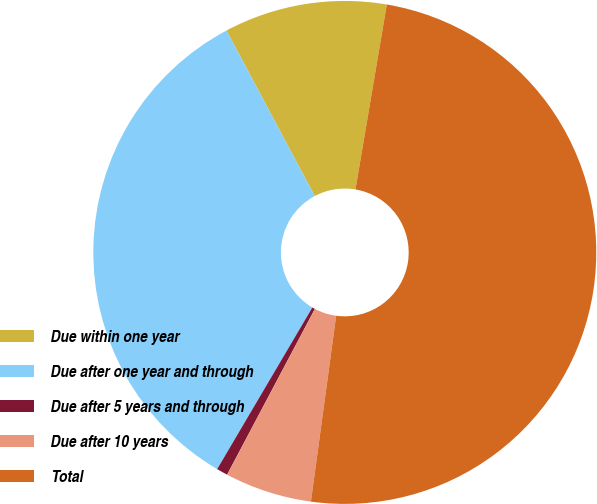Convert chart to OTSL. <chart><loc_0><loc_0><loc_500><loc_500><pie_chart><fcel>Due within one year<fcel>Due after one year and through<fcel>Due after 5 years and through<fcel>Due after 10 years<fcel>Total<nl><fcel>10.47%<fcel>33.73%<fcel>0.72%<fcel>5.6%<fcel>49.48%<nl></chart> 